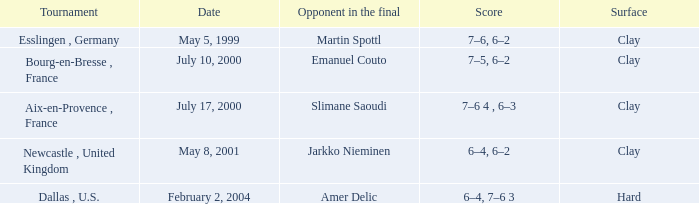What is the Date of the game with a Score of 6–4, 6–2? May 8, 2001. 